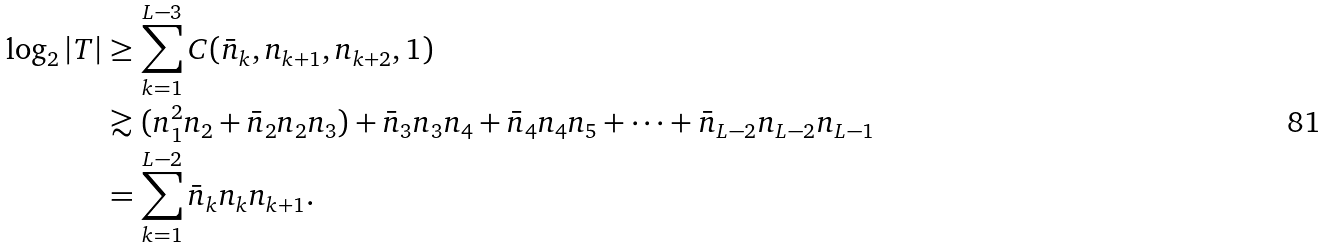Convert formula to latex. <formula><loc_0><loc_0><loc_500><loc_500>\log _ { 2 } | T | & \geq \sum _ { k = 1 } ^ { L - 3 } C ( \bar { n } _ { k } , n _ { k + 1 } , n _ { k + 2 } , 1 ) \\ & \gtrsim ( n _ { 1 } ^ { 2 } n _ { 2 } + \bar { n } _ { 2 } n _ { 2 } n _ { 3 } ) + \bar { n } _ { 3 } n _ { 3 } n _ { 4 } + \bar { n } _ { 4 } n _ { 4 } n _ { 5 } + \cdots + \bar { n } _ { L - 2 } n _ { L - 2 } n _ { L - 1 } \\ & = \sum _ { k = 1 } ^ { L - 2 } \bar { n } _ { k } n _ { k } n _ { k + 1 } .</formula> 